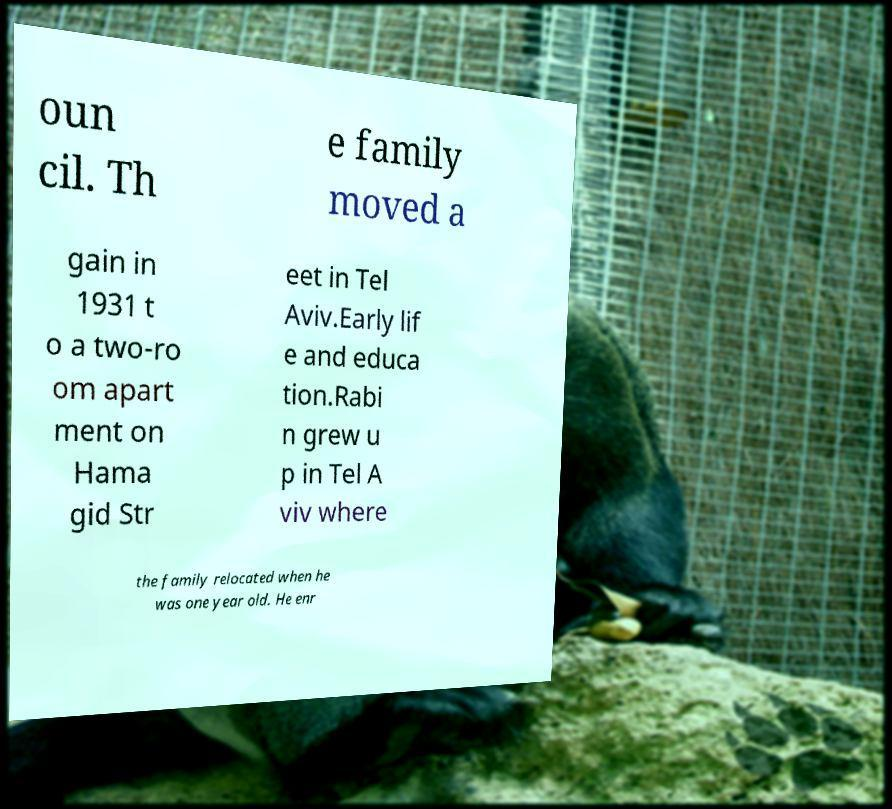There's text embedded in this image that I need extracted. Can you transcribe it verbatim? oun cil. Th e family moved a gain in 1931 t o a two-ro om apart ment on Hama gid Str eet in Tel Aviv.Early lif e and educa tion.Rabi n grew u p in Tel A viv where the family relocated when he was one year old. He enr 